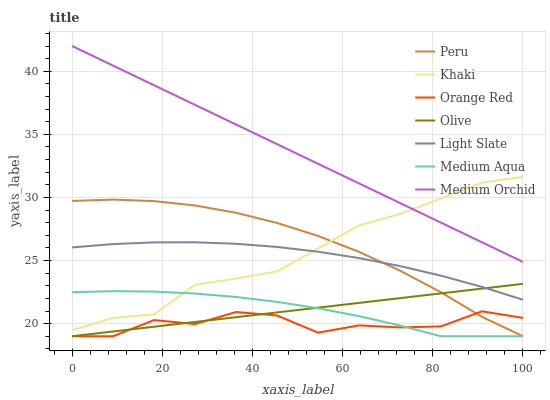Does Orange Red have the minimum area under the curve?
Answer yes or no. Yes. Does Medium Orchid have the maximum area under the curve?
Answer yes or no. Yes. Does Light Slate have the minimum area under the curve?
Answer yes or no. No. Does Light Slate have the maximum area under the curve?
Answer yes or no. No. Is Olive the smoothest?
Answer yes or no. Yes. Is Orange Red the roughest?
Answer yes or no. Yes. Is Light Slate the smoothest?
Answer yes or no. No. Is Light Slate the roughest?
Answer yes or no. No. Does Medium Aqua have the lowest value?
Answer yes or no. Yes. Does Light Slate have the lowest value?
Answer yes or no. No. Does Medium Orchid have the highest value?
Answer yes or no. Yes. Does Light Slate have the highest value?
Answer yes or no. No. Is Olive less than Medium Orchid?
Answer yes or no. Yes. Is Medium Orchid greater than Light Slate?
Answer yes or no. Yes. Does Medium Aqua intersect Peru?
Answer yes or no. Yes. Is Medium Aqua less than Peru?
Answer yes or no. No. Is Medium Aqua greater than Peru?
Answer yes or no. No. Does Olive intersect Medium Orchid?
Answer yes or no. No. 